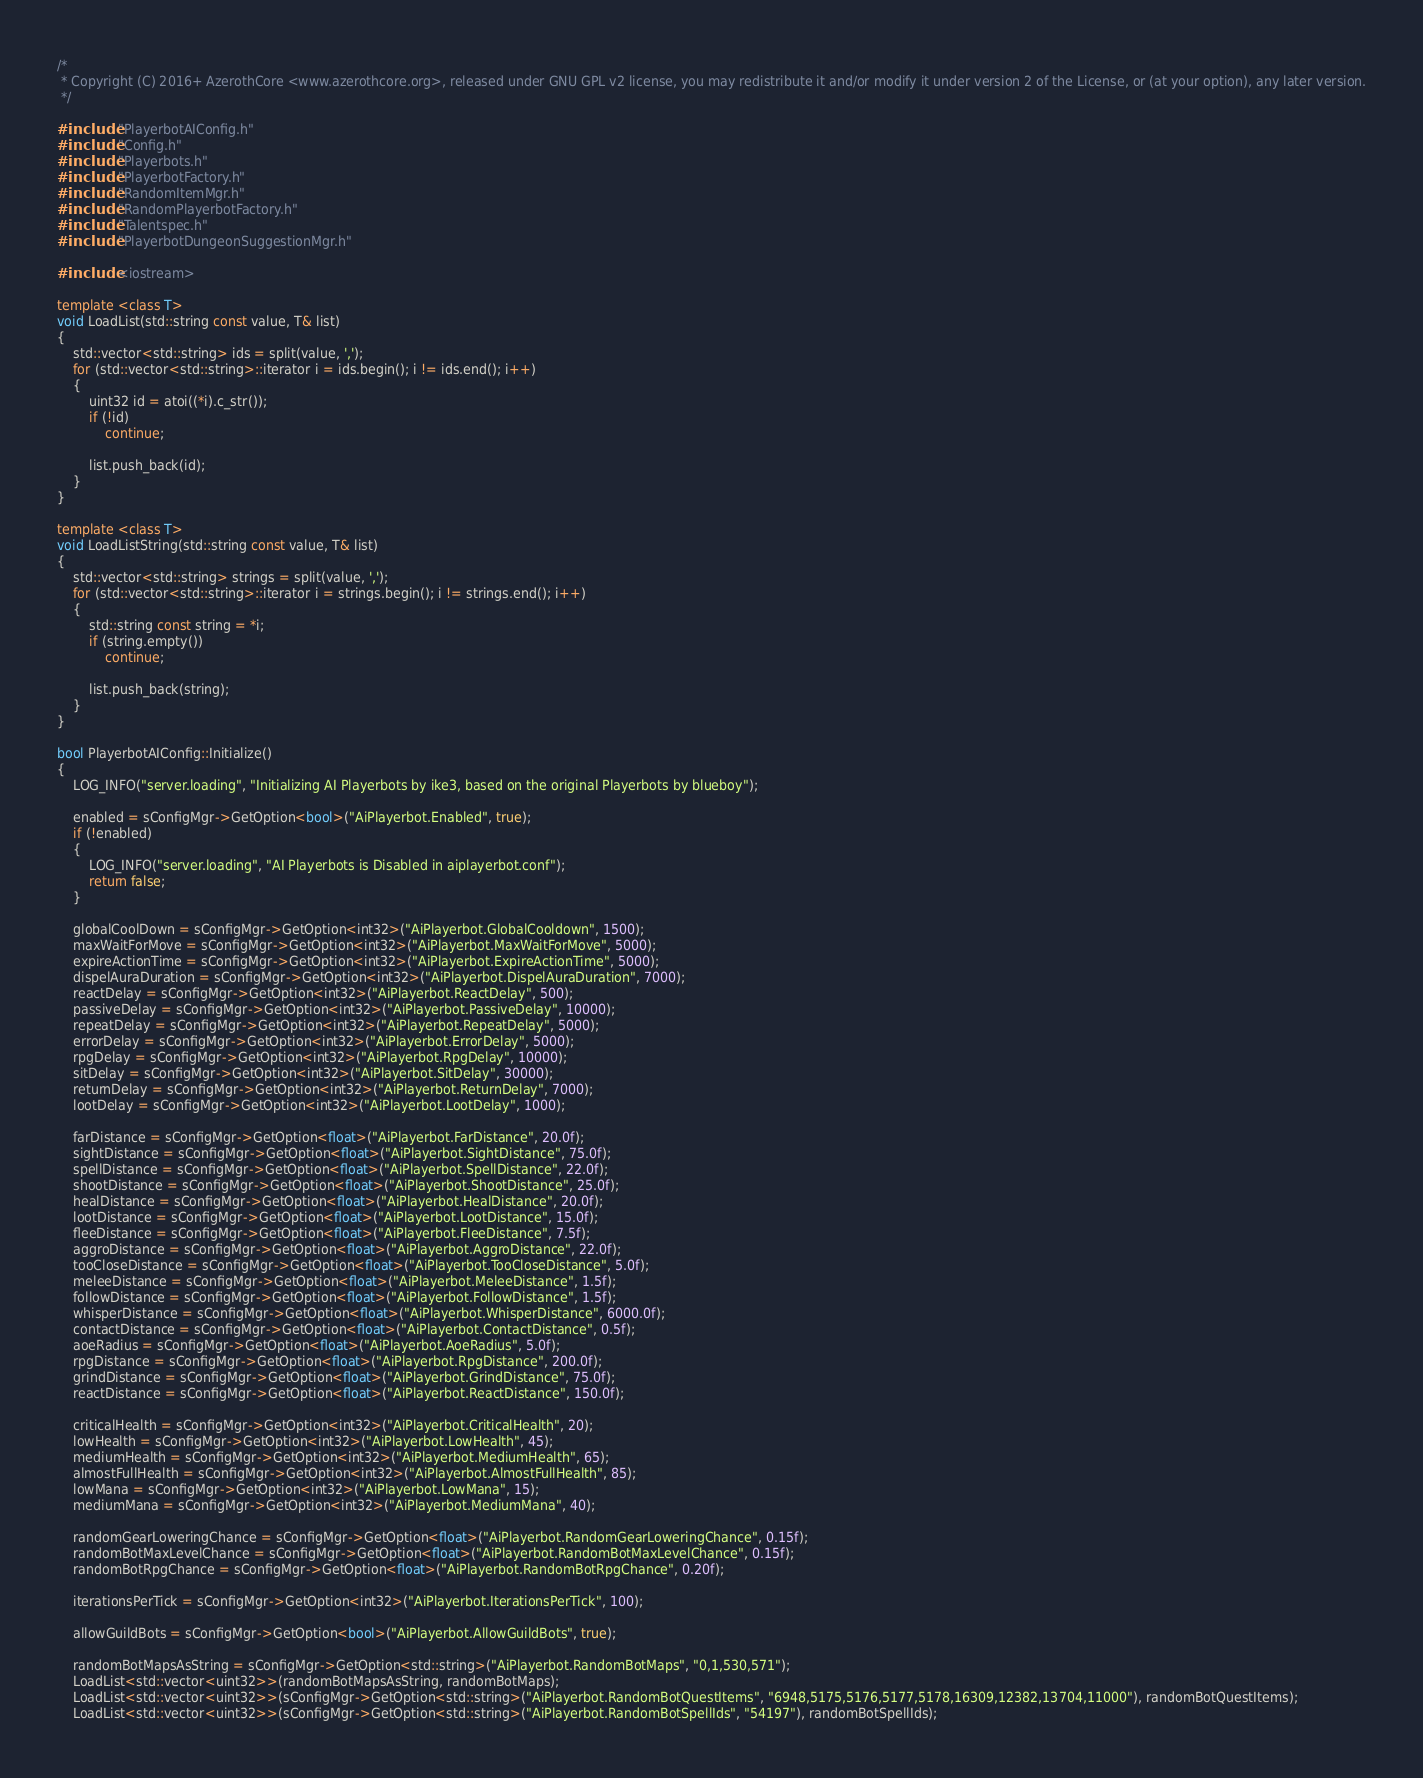Convert code to text. <code><loc_0><loc_0><loc_500><loc_500><_C++_>/*
 * Copyright (C) 2016+ AzerothCore <www.azerothcore.org>, released under GNU GPL v2 license, you may redistribute it and/or modify it under version 2 of the License, or (at your option), any later version.
 */

#include "PlayerbotAIConfig.h"
#include "Config.h"
#include "Playerbots.h"
#include "PlayerbotFactory.h"
#include "RandomItemMgr.h"
#include "RandomPlayerbotFactory.h"
#include "Talentspec.h"
#include "PlayerbotDungeonSuggestionMgr.h"

#include <iostream>

template <class T>
void LoadList(std::string const value, T& list)
{
    std::vector<std::string> ids = split(value, ',');
    for (std::vector<std::string>::iterator i = ids.begin(); i != ids.end(); i++)
    {
        uint32 id = atoi((*i).c_str());
        if (!id)
            continue;

        list.push_back(id);
    }
}

template <class T>
void LoadListString(std::string const value, T& list)
{
    std::vector<std::string> strings = split(value, ',');
    for (std::vector<std::string>::iterator i = strings.begin(); i != strings.end(); i++)
    {
        std::string const string = *i;
        if (string.empty())
            continue;

        list.push_back(string);
    }
}

bool PlayerbotAIConfig::Initialize()
{
    LOG_INFO("server.loading", "Initializing AI Playerbots by ike3, based on the original Playerbots by blueboy");

    enabled = sConfigMgr->GetOption<bool>("AiPlayerbot.Enabled", true);
    if (!enabled)
    {
        LOG_INFO("server.loading", "AI Playerbots is Disabled in aiplayerbot.conf");
        return false;
    }

    globalCoolDown = sConfigMgr->GetOption<int32>("AiPlayerbot.GlobalCooldown", 1500);
    maxWaitForMove = sConfigMgr->GetOption<int32>("AiPlayerbot.MaxWaitForMove", 5000);
    expireActionTime = sConfigMgr->GetOption<int32>("AiPlayerbot.ExpireActionTime", 5000);
    dispelAuraDuration = sConfigMgr->GetOption<int32>("AiPlayerbot.DispelAuraDuration", 7000);
    reactDelay = sConfigMgr->GetOption<int32>("AiPlayerbot.ReactDelay", 500);
    passiveDelay = sConfigMgr->GetOption<int32>("AiPlayerbot.PassiveDelay", 10000);
    repeatDelay = sConfigMgr->GetOption<int32>("AiPlayerbot.RepeatDelay", 5000);
    errorDelay = sConfigMgr->GetOption<int32>("AiPlayerbot.ErrorDelay", 5000);
    rpgDelay = sConfigMgr->GetOption<int32>("AiPlayerbot.RpgDelay", 10000);
    sitDelay = sConfigMgr->GetOption<int32>("AiPlayerbot.SitDelay", 30000);
    returnDelay = sConfigMgr->GetOption<int32>("AiPlayerbot.ReturnDelay", 7000);
    lootDelay = sConfigMgr->GetOption<int32>("AiPlayerbot.LootDelay", 1000);

    farDistance = sConfigMgr->GetOption<float>("AiPlayerbot.FarDistance", 20.0f);
    sightDistance = sConfigMgr->GetOption<float>("AiPlayerbot.SightDistance", 75.0f);
    spellDistance = sConfigMgr->GetOption<float>("AiPlayerbot.SpellDistance", 22.0f);
    shootDistance = sConfigMgr->GetOption<float>("AiPlayerbot.ShootDistance", 25.0f);
    healDistance = sConfigMgr->GetOption<float>("AiPlayerbot.HealDistance", 20.0f);
    lootDistance = sConfigMgr->GetOption<float>("AiPlayerbot.LootDistance", 15.0f);
    fleeDistance = sConfigMgr->GetOption<float>("AiPlayerbot.FleeDistance", 7.5f);
    aggroDistance = sConfigMgr->GetOption<float>("AiPlayerbot.AggroDistance", 22.0f);
    tooCloseDistance = sConfigMgr->GetOption<float>("AiPlayerbot.TooCloseDistance", 5.0f);
    meleeDistance = sConfigMgr->GetOption<float>("AiPlayerbot.MeleeDistance", 1.5f);
    followDistance = sConfigMgr->GetOption<float>("AiPlayerbot.FollowDistance", 1.5f);
    whisperDistance = sConfigMgr->GetOption<float>("AiPlayerbot.WhisperDistance", 6000.0f);
    contactDistance = sConfigMgr->GetOption<float>("AiPlayerbot.ContactDistance", 0.5f);
    aoeRadius = sConfigMgr->GetOption<float>("AiPlayerbot.AoeRadius", 5.0f);
    rpgDistance = sConfigMgr->GetOption<float>("AiPlayerbot.RpgDistance", 200.0f);
    grindDistance = sConfigMgr->GetOption<float>("AiPlayerbot.GrindDistance", 75.0f);
    reactDistance = sConfigMgr->GetOption<float>("AiPlayerbot.ReactDistance", 150.0f);

    criticalHealth = sConfigMgr->GetOption<int32>("AiPlayerbot.CriticalHealth", 20);
    lowHealth = sConfigMgr->GetOption<int32>("AiPlayerbot.LowHealth", 45);
    mediumHealth = sConfigMgr->GetOption<int32>("AiPlayerbot.MediumHealth", 65);
    almostFullHealth = sConfigMgr->GetOption<int32>("AiPlayerbot.AlmostFullHealth", 85);
    lowMana = sConfigMgr->GetOption<int32>("AiPlayerbot.LowMana", 15);
    mediumMana = sConfigMgr->GetOption<int32>("AiPlayerbot.MediumMana", 40);

    randomGearLoweringChance = sConfigMgr->GetOption<float>("AiPlayerbot.RandomGearLoweringChance", 0.15f);
    randomBotMaxLevelChance = sConfigMgr->GetOption<float>("AiPlayerbot.RandomBotMaxLevelChance", 0.15f);
    randomBotRpgChance = sConfigMgr->GetOption<float>("AiPlayerbot.RandomBotRpgChance", 0.20f);

    iterationsPerTick = sConfigMgr->GetOption<int32>("AiPlayerbot.IterationsPerTick", 100);

    allowGuildBots = sConfigMgr->GetOption<bool>("AiPlayerbot.AllowGuildBots", true);

    randomBotMapsAsString = sConfigMgr->GetOption<std::string>("AiPlayerbot.RandomBotMaps", "0,1,530,571");
    LoadList<std::vector<uint32>>(randomBotMapsAsString, randomBotMaps);
    LoadList<std::vector<uint32>>(sConfigMgr->GetOption<std::string>("AiPlayerbot.RandomBotQuestItems", "6948,5175,5176,5177,5178,16309,12382,13704,11000"), randomBotQuestItems);
    LoadList<std::vector<uint32>>(sConfigMgr->GetOption<std::string>("AiPlayerbot.RandomBotSpellIds", "54197"), randomBotSpellIds);</code> 